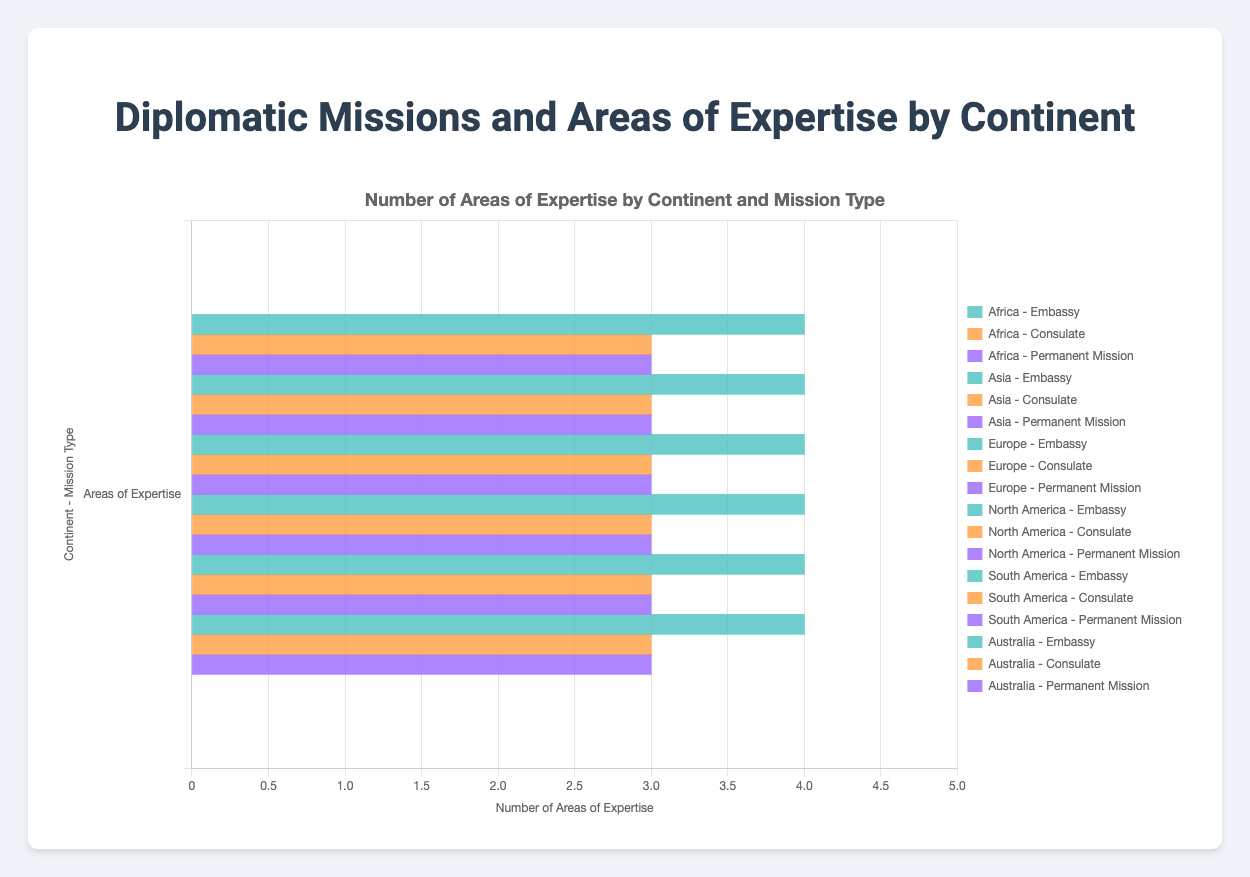Which continent has the most areas of expertise in its embassies? By comparing the length of the horizontal bars for embassies across all continents, we see that embassies in Africa, Asia, Europe, and North America each have the longest bars indicating 4 areas of expertise. Therefore, they tie for the most areas of expertise in their embassies.
Answer: Africa, Asia, Europe, North America Are the areas of expertise for consulates less than those for embassies across all continents? By visually comparing the lengths of the bars for consulates and embassies across all continents, we see that consulates have shorter bars indicating 3 areas of expertise, while embassies have longer bars indicating 4 areas of expertise. Therefore, consulates indeed have fewer areas of expertise.
Answer: Yes Which mission type in South America has the most areas of expertise? By looking at the bars specifically under South America, we compare the lengths and see the embassy has a bar indicating 4 areas of expertise, while both the consulate and permanent mission have bars indicating 3 areas each. Thus, the embassy has the most areas of expertise.
Answer: Embassy How many total areas of expertise are there for permanent missions in Asia and Europe combined? First, identify the number of areas of expertise for permanent missions in Asia and Europe. Asia has 3 (Disarmament Affairs, Climate Change Mitigation, Technology Collaboration), and Europe has 3 (Environmental Policy, Multilateral Negotiations, Human Rights Advocacy). Summing these gives 3 + 3 = 6.
Answer: 6 Which mission type has consistent areas of expertise across all continents? By observing the figure, we see consulates have the same length for all continents, indicating they all have 3 areas of expertise (Consular Services, Trade and Investment Promotion, Cultural Diplomacy).
Answer: Consulate Does Australia have the most areas of expertise for permanent missions compared to other continents? Checking the bars for permanent missions across all continents, we see that Australia, Africa, Asia, Europe, North America, and South America each have bars indicating 3 areas of expertise. Therefore, Australia ties with others and doesn't have the most.
Answer: No Which continent has the least areas of expertise in its consulates? By comparing the lengths of the bars for consulates across all continents, they all have equal lengths indicating 3 areas of expertise. Therefore, no continent has fewer areas of expertise in its consulates.
Answer: None What is the sum of areas of expertise for embassies in Africa and North America? Embassies in Africa have 4 areas of expertise (Political Affairs, Economic Development, Public Diplomacy, Security Cooperation), and embassies in North America also have 4 (Political Affairs, Economic Development, Public Diplomacy, Defense Relations). Summing these gives 4 + 4 = 8.
Answer: 8 Is there any continent where embassies have fewer areas of expertise than permanent missions? By visually comparing embassy and permanent mission bars for each continent, we see that embassies always equal or exceed the length of bars representing permanent missions. Therefore, there isn't any continent where embassies have fewer areas of expertise than permanent missions.
Answer: No 